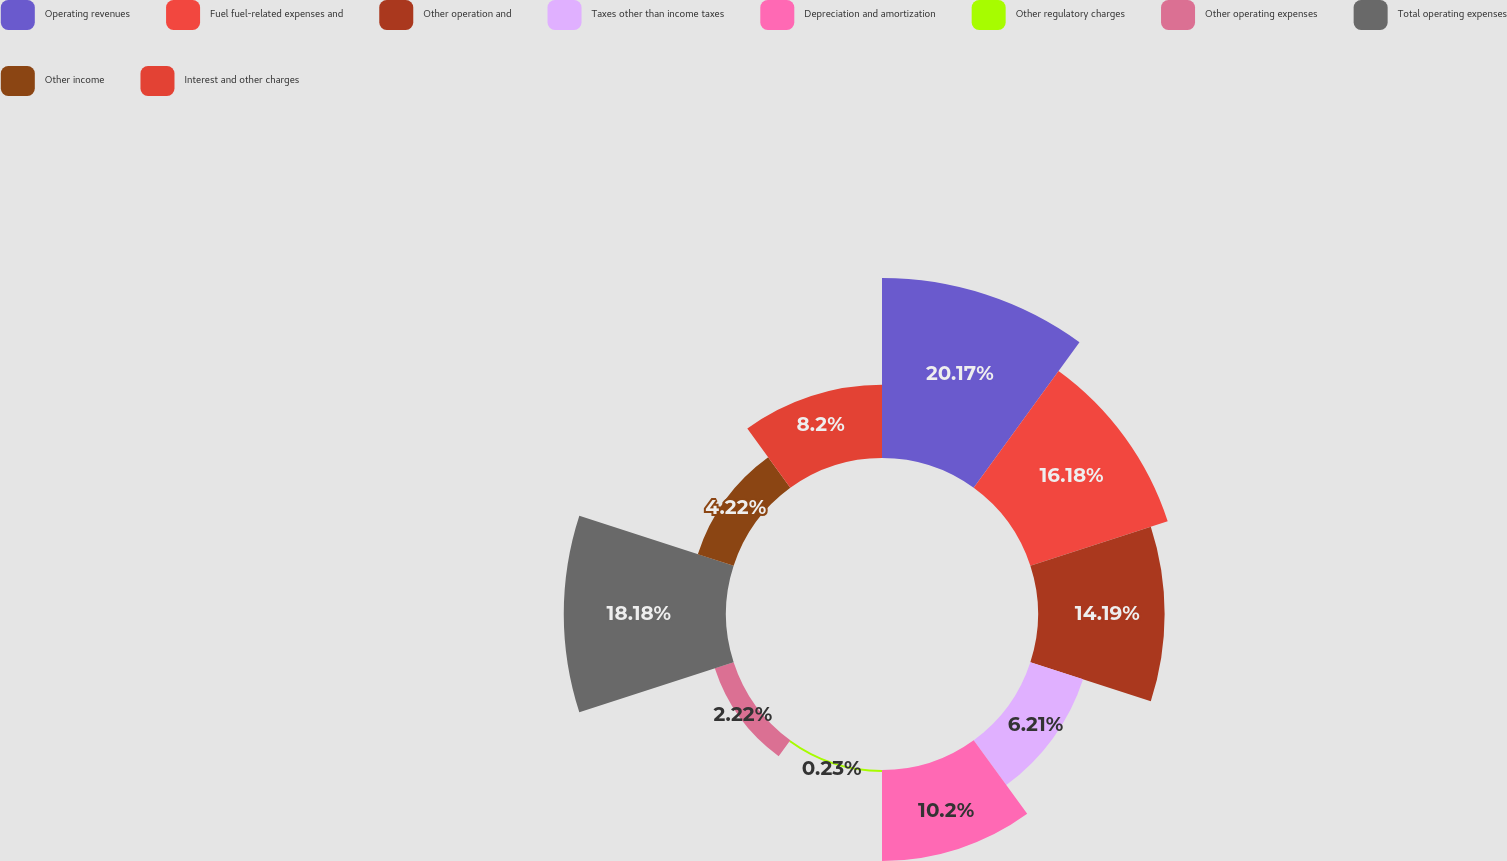Convert chart to OTSL. <chart><loc_0><loc_0><loc_500><loc_500><pie_chart><fcel>Operating revenues<fcel>Fuel fuel-related expenses and<fcel>Other operation and<fcel>Taxes other than income taxes<fcel>Depreciation and amortization<fcel>Other regulatory charges<fcel>Other operating expenses<fcel>Total operating expenses<fcel>Other income<fcel>Interest and other charges<nl><fcel>20.17%<fcel>16.18%<fcel>14.19%<fcel>6.21%<fcel>10.2%<fcel>0.23%<fcel>2.22%<fcel>18.18%<fcel>4.22%<fcel>8.2%<nl></chart> 